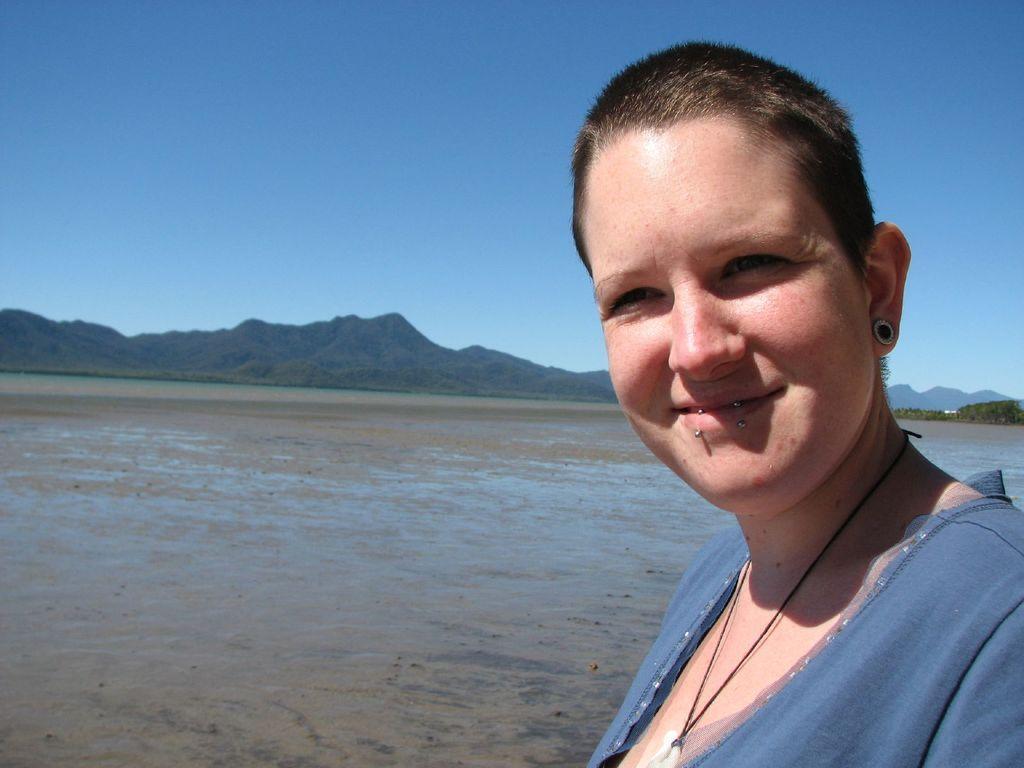Please provide a concise description of this image. In the image I can see a woman is smiling. The woman is wearing grey color clothes. In the background I can see mountains, the sky and the water. 